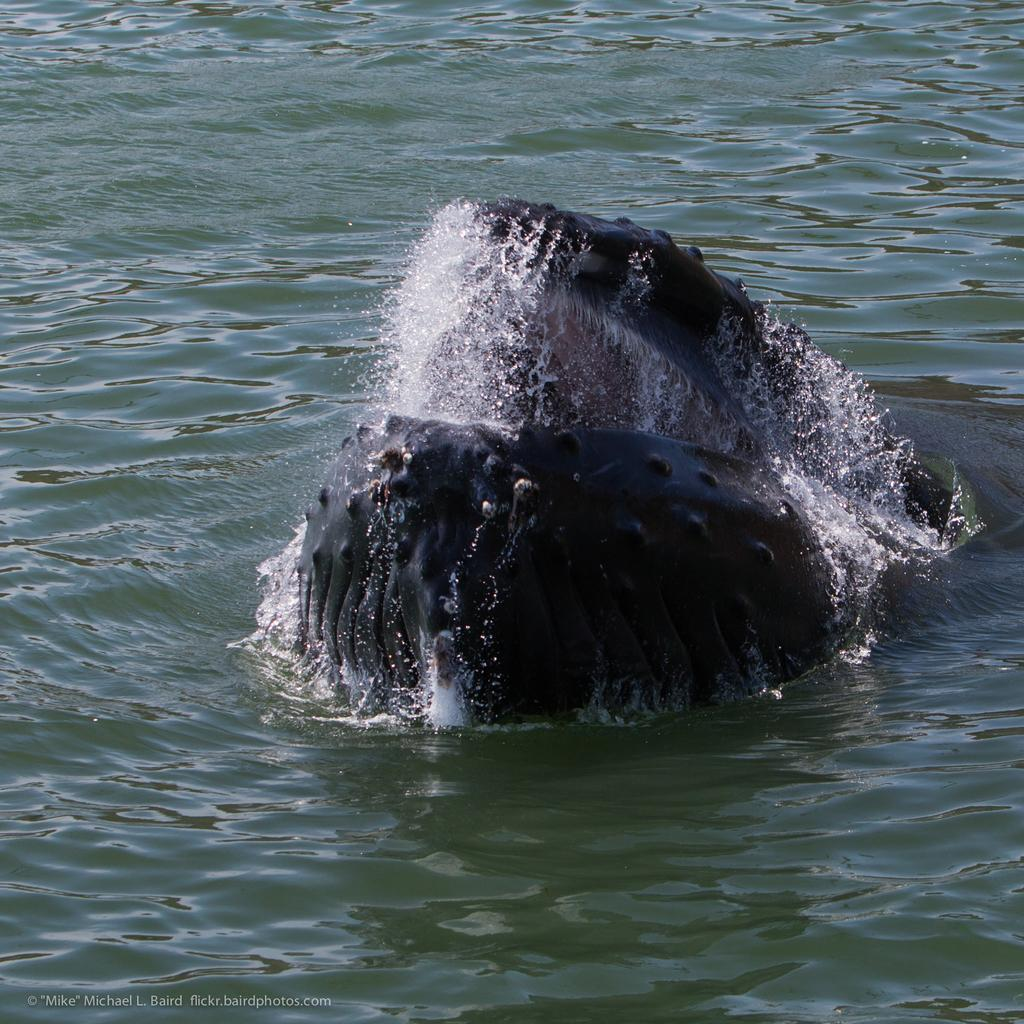What is the main subject of the picture? The main subject of the picture is a whale. What is the primary setting or environment in the image? There is water visible in the picture, suggesting that the whale is in its natural aquatic habitat. What type of paper can be seen in the image? There is no paper present in the image; it features a whale in water. What is the color of the wristband on the whale in the image? There are no wristbands or any other accessories visible on the whale in the image. 